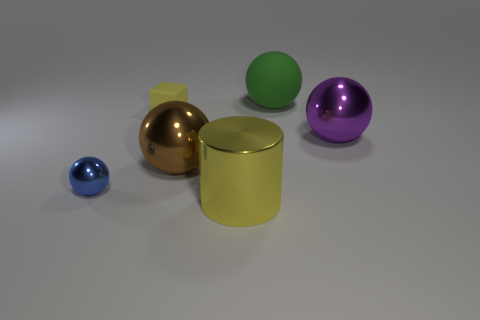Add 1 tiny gray metal spheres. How many objects exist? 7 Subtract all rubber spheres. How many spheres are left? 3 Subtract all purple spheres. How many spheres are left? 3 Subtract 1 purple spheres. How many objects are left? 5 Subtract all spheres. How many objects are left? 2 Subtract 1 cubes. How many cubes are left? 0 Subtract all purple balls. Subtract all yellow cylinders. How many balls are left? 3 Subtract all green blocks. How many brown spheres are left? 1 Subtract all big balls. Subtract all cylinders. How many objects are left? 2 Add 1 large rubber spheres. How many large rubber spheres are left? 2 